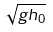Convert formula to latex. <formula><loc_0><loc_0><loc_500><loc_500>\sqrt { g h _ { 0 } }</formula> 